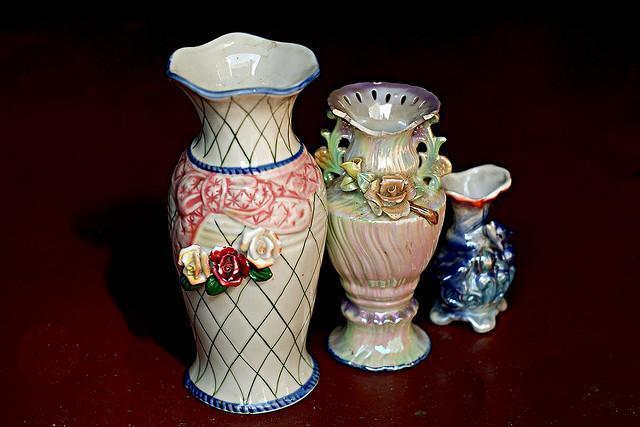How many of the roses are red?
Give a very brief answer. 1. How many vases on the table?
Give a very brief answer. 3. How many vases are there?
Give a very brief answer. 3. 